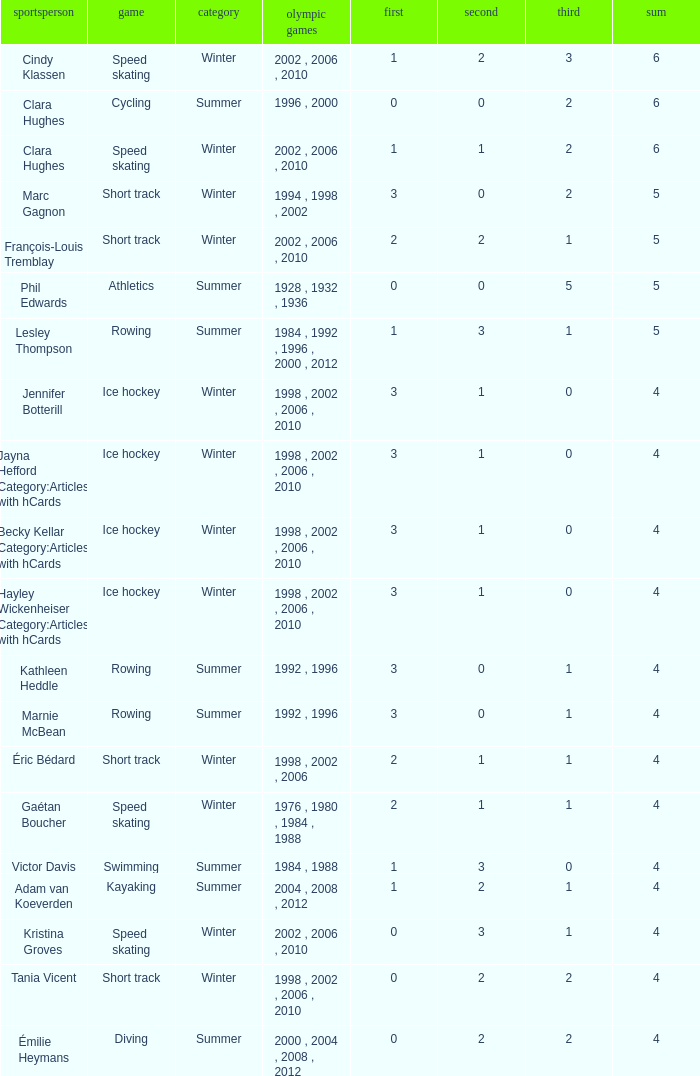What is the lowest number of bronze a short track athlete with 0 gold medals has? 2.0. 